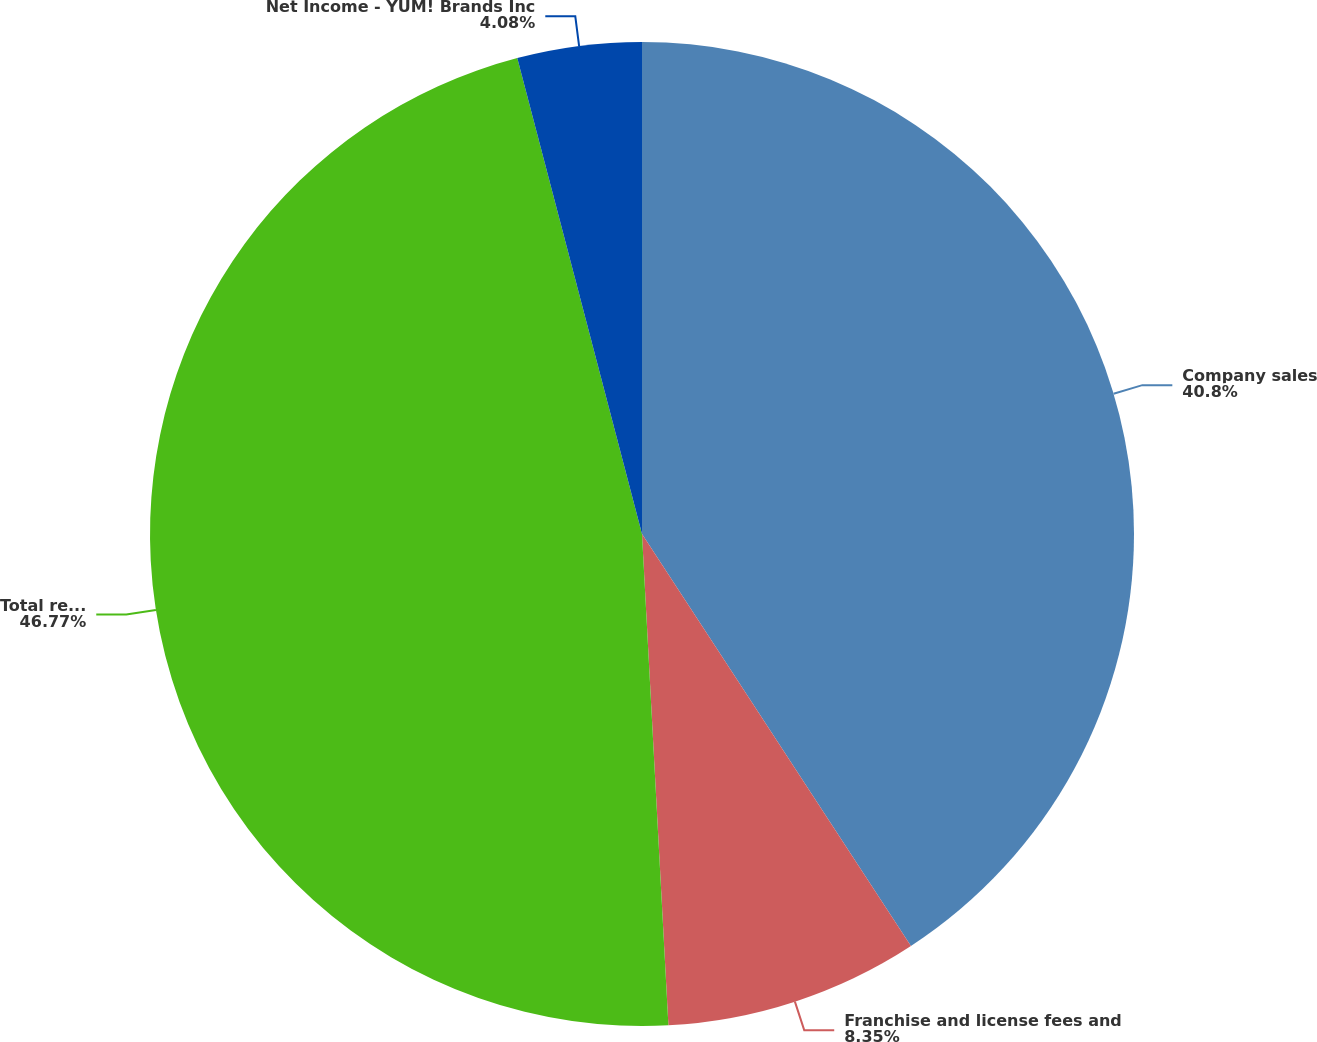Convert chart to OTSL. <chart><loc_0><loc_0><loc_500><loc_500><pie_chart><fcel>Company sales<fcel>Franchise and license fees and<fcel>Total revenues<fcel>Net Income - YUM! Brands Inc<nl><fcel>40.8%<fcel>8.35%<fcel>46.78%<fcel>4.08%<nl></chart> 